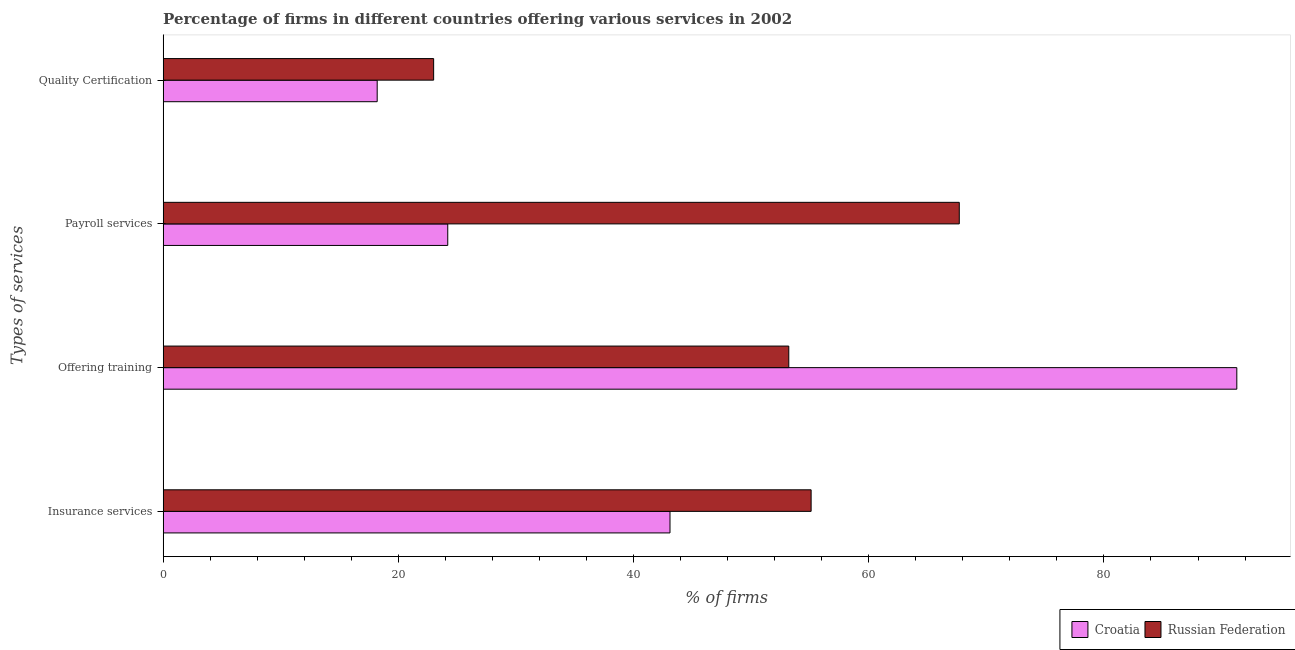What is the label of the 2nd group of bars from the top?
Keep it short and to the point. Payroll services. What is the percentage of firms offering insurance services in Croatia?
Ensure brevity in your answer.  43.1. Across all countries, what is the maximum percentage of firms offering payroll services?
Keep it short and to the point. 67.7. In which country was the percentage of firms offering insurance services maximum?
Ensure brevity in your answer.  Russian Federation. In which country was the percentage of firms offering training minimum?
Ensure brevity in your answer.  Russian Federation. What is the total percentage of firms offering insurance services in the graph?
Your answer should be compact. 98.2. What is the difference between the percentage of firms offering training in Croatia and that in Russian Federation?
Make the answer very short. 38.1. What is the difference between the percentage of firms offering training in Croatia and the percentage of firms offering payroll services in Russian Federation?
Offer a terse response. 23.6. What is the average percentage of firms offering payroll services per country?
Offer a terse response. 45.95. What is the difference between the percentage of firms offering payroll services and percentage of firms offering insurance services in Croatia?
Make the answer very short. -18.9. What is the ratio of the percentage of firms offering training in Russian Federation to that in Croatia?
Your answer should be compact. 0.58. What is the difference between the highest and the second highest percentage of firms offering training?
Make the answer very short. 38.1. What is the difference between the highest and the lowest percentage of firms offering payroll services?
Offer a very short reply. 43.5. In how many countries, is the percentage of firms offering insurance services greater than the average percentage of firms offering insurance services taken over all countries?
Your answer should be compact. 1. Is the sum of the percentage of firms offering quality certification in Croatia and Russian Federation greater than the maximum percentage of firms offering training across all countries?
Keep it short and to the point. No. What does the 2nd bar from the top in Offering training represents?
Keep it short and to the point. Croatia. What does the 2nd bar from the bottom in Quality Certification represents?
Keep it short and to the point. Russian Federation. How many bars are there?
Make the answer very short. 8. Are all the bars in the graph horizontal?
Your response must be concise. Yes. How many countries are there in the graph?
Give a very brief answer. 2. Are the values on the major ticks of X-axis written in scientific E-notation?
Give a very brief answer. No. Does the graph contain grids?
Your response must be concise. No. Where does the legend appear in the graph?
Provide a succinct answer. Bottom right. What is the title of the graph?
Your answer should be very brief. Percentage of firms in different countries offering various services in 2002. What is the label or title of the X-axis?
Keep it short and to the point. % of firms. What is the label or title of the Y-axis?
Your response must be concise. Types of services. What is the % of firms of Croatia in Insurance services?
Your answer should be very brief. 43.1. What is the % of firms of Russian Federation in Insurance services?
Give a very brief answer. 55.1. What is the % of firms in Croatia in Offering training?
Your response must be concise. 91.3. What is the % of firms of Russian Federation in Offering training?
Give a very brief answer. 53.2. What is the % of firms in Croatia in Payroll services?
Your answer should be compact. 24.2. What is the % of firms in Russian Federation in Payroll services?
Provide a short and direct response. 67.7. What is the % of firms in Russian Federation in Quality Certification?
Make the answer very short. 23. Across all Types of services, what is the maximum % of firms in Croatia?
Offer a very short reply. 91.3. Across all Types of services, what is the maximum % of firms in Russian Federation?
Provide a short and direct response. 67.7. Across all Types of services, what is the minimum % of firms of Russian Federation?
Keep it short and to the point. 23. What is the total % of firms of Croatia in the graph?
Give a very brief answer. 176.8. What is the total % of firms in Russian Federation in the graph?
Provide a short and direct response. 199. What is the difference between the % of firms in Croatia in Insurance services and that in Offering training?
Your answer should be compact. -48.2. What is the difference between the % of firms in Russian Federation in Insurance services and that in Offering training?
Give a very brief answer. 1.9. What is the difference between the % of firms in Russian Federation in Insurance services and that in Payroll services?
Offer a very short reply. -12.6. What is the difference between the % of firms in Croatia in Insurance services and that in Quality Certification?
Your answer should be very brief. 24.9. What is the difference between the % of firms of Russian Federation in Insurance services and that in Quality Certification?
Make the answer very short. 32.1. What is the difference between the % of firms of Croatia in Offering training and that in Payroll services?
Offer a terse response. 67.1. What is the difference between the % of firms in Croatia in Offering training and that in Quality Certification?
Provide a short and direct response. 73.1. What is the difference between the % of firms in Russian Federation in Offering training and that in Quality Certification?
Make the answer very short. 30.2. What is the difference between the % of firms of Russian Federation in Payroll services and that in Quality Certification?
Your response must be concise. 44.7. What is the difference between the % of firms of Croatia in Insurance services and the % of firms of Russian Federation in Offering training?
Provide a succinct answer. -10.1. What is the difference between the % of firms of Croatia in Insurance services and the % of firms of Russian Federation in Payroll services?
Your answer should be compact. -24.6. What is the difference between the % of firms of Croatia in Insurance services and the % of firms of Russian Federation in Quality Certification?
Offer a very short reply. 20.1. What is the difference between the % of firms in Croatia in Offering training and the % of firms in Russian Federation in Payroll services?
Your response must be concise. 23.6. What is the difference between the % of firms of Croatia in Offering training and the % of firms of Russian Federation in Quality Certification?
Your answer should be compact. 68.3. What is the average % of firms of Croatia per Types of services?
Give a very brief answer. 44.2. What is the average % of firms of Russian Federation per Types of services?
Provide a succinct answer. 49.75. What is the difference between the % of firms in Croatia and % of firms in Russian Federation in Offering training?
Give a very brief answer. 38.1. What is the difference between the % of firms in Croatia and % of firms in Russian Federation in Payroll services?
Provide a short and direct response. -43.5. What is the ratio of the % of firms in Croatia in Insurance services to that in Offering training?
Your answer should be compact. 0.47. What is the ratio of the % of firms in Russian Federation in Insurance services to that in Offering training?
Your answer should be compact. 1.04. What is the ratio of the % of firms in Croatia in Insurance services to that in Payroll services?
Provide a short and direct response. 1.78. What is the ratio of the % of firms of Russian Federation in Insurance services to that in Payroll services?
Make the answer very short. 0.81. What is the ratio of the % of firms in Croatia in Insurance services to that in Quality Certification?
Offer a very short reply. 2.37. What is the ratio of the % of firms of Russian Federation in Insurance services to that in Quality Certification?
Offer a very short reply. 2.4. What is the ratio of the % of firms in Croatia in Offering training to that in Payroll services?
Your answer should be compact. 3.77. What is the ratio of the % of firms of Russian Federation in Offering training to that in Payroll services?
Your answer should be compact. 0.79. What is the ratio of the % of firms in Croatia in Offering training to that in Quality Certification?
Provide a short and direct response. 5.02. What is the ratio of the % of firms of Russian Federation in Offering training to that in Quality Certification?
Provide a short and direct response. 2.31. What is the ratio of the % of firms in Croatia in Payroll services to that in Quality Certification?
Provide a succinct answer. 1.33. What is the ratio of the % of firms of Russian Federation in Payroll services to that in Quality Certification?
Offer a very short reply. 2.94. What is the difference between the highest and the second highest % of firms of Croatia?
Offer a very short reply. 48.2. What is the difference between the highest and the second highest % of firms of Russian Federation?
Your response must be concise. 12.6. What is the difference between the highest and the lowest % of firms in Croatia?
Keep it short and to the point. 73.1. What is the difference between the highest and the lowest % of firms in Russian Federation?
Make the answer very short. 44.7. 